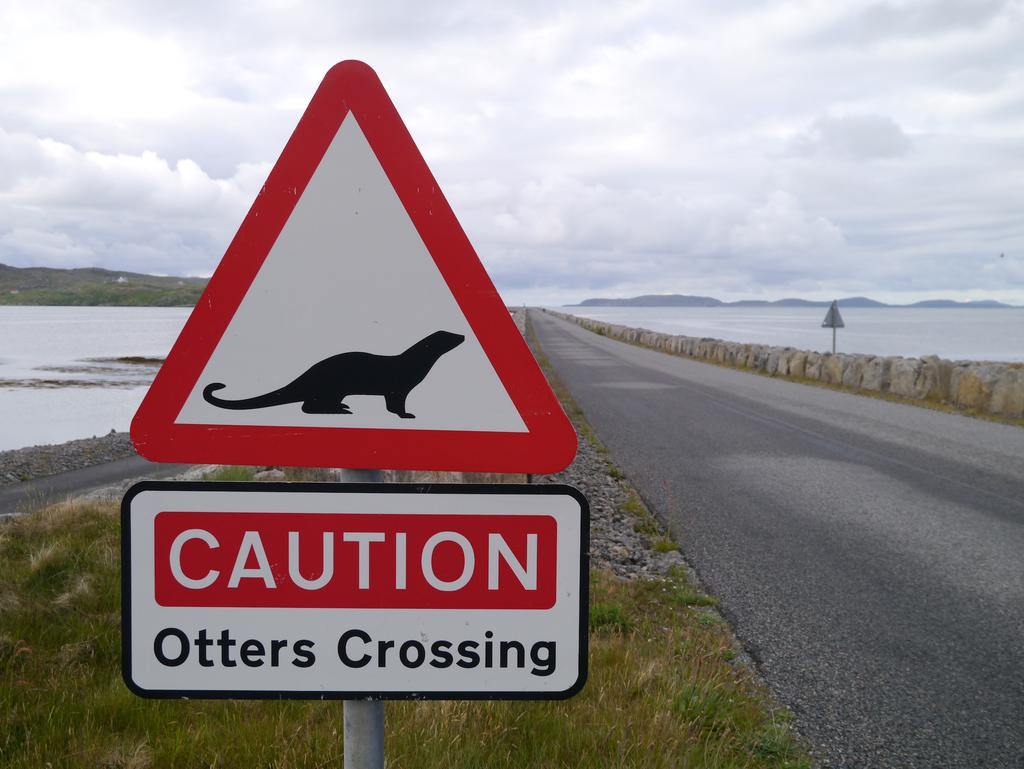<image>
Share a concise interpretation of the image provided. A red triangular street sign with the words Caution Otters Crossing on the bottom of it. 